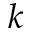Convert formula to latex. <formula><loc_0><loc_0><loc_500><loc_500>k</formula> 